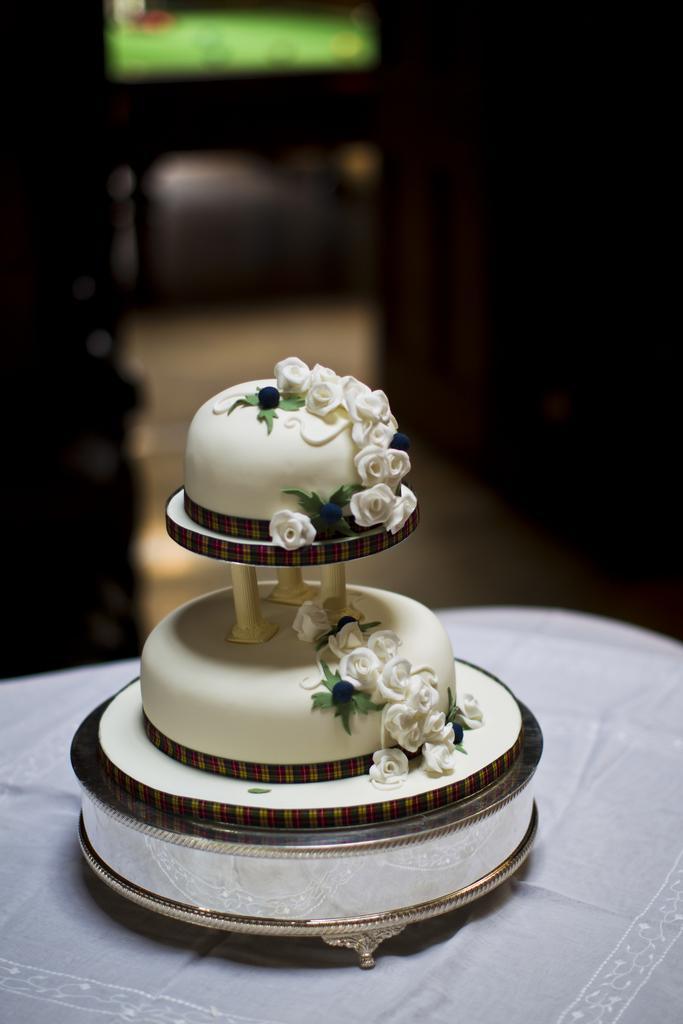Describe this image in one or two sentences. In the middle of the image we can see a cake, and we can see blurry background. 